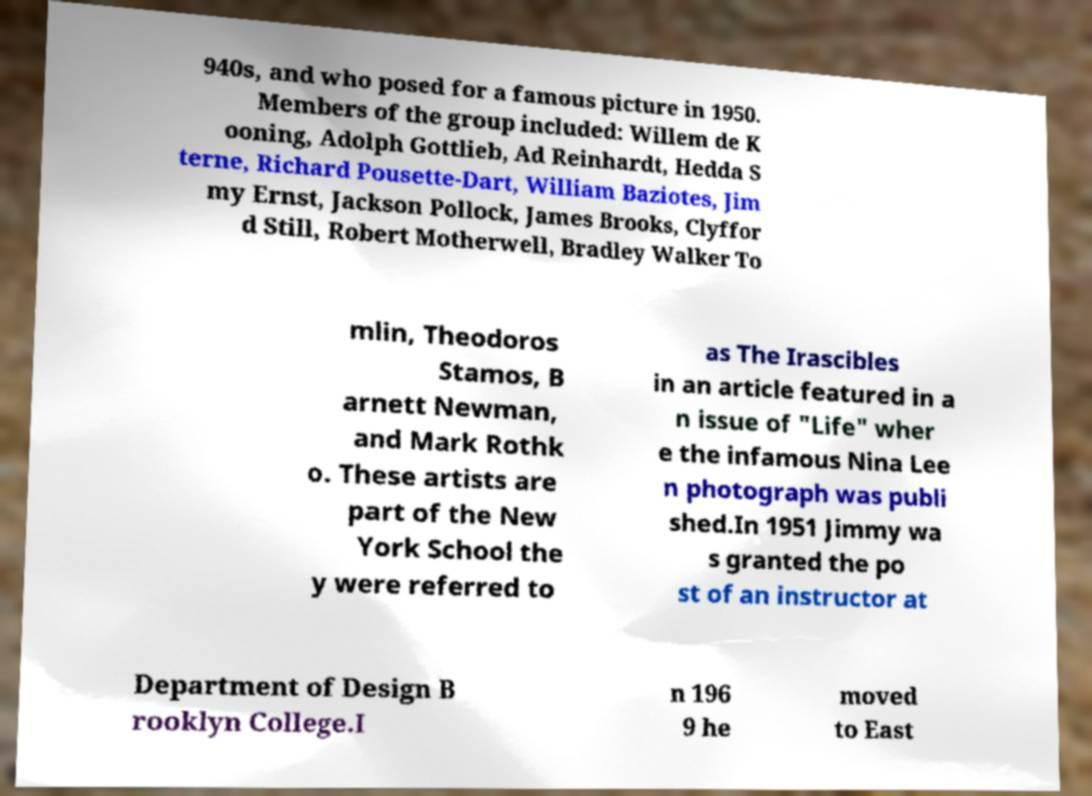Could you extract and type out the text from this image? 940s, and who posed for a famous picture in 1950. Members of the group included: Willem de K ooning, Adolph Gottlieb, Ad Reinhardt, Hedda S terne, Richard Pousette-Dart, William Baziotes, Jim my Ernst, Jackson Pollock, James Brooks, Clyffor d Still, Robert Motherwell, Bradley Walker To mlin, Theodoros Stamos, B arnett Newman, and Mark Rothk o. These artists are part of the New York School the y were referred to as The Irascibles in an article featured in a n issue of "Life" wher e the infamous Nina Lee n photograph was publi shed.In 1951 Jimmy wa s granted the po st of an instructor at Department of Design B rooklyn College.I n 196 9 he moved to East 